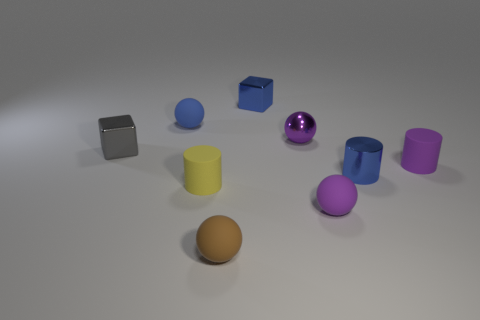There is a metallic thing that is behind the small gray block and in front of the tiny blue rubber object; how big is it?
Give a very brief answer. Small. There is another tiny sphere that is the same color as the small metal sphere; what is its material?
Make the answer very short. Rubber. Are there an equal number of tiny blue metallic cylinders that are behind the brown matte sphere and small purple matte cylinders?
Your response must be concise. Yes. Do the blue shiny cube and the gray block have the same size?
Provide a succinct answer. Yes. There is a tiny sphere that is both on the left side of the small purple metal object and in front of the tiny blue sphere; what is its color?
Your answer should be very brief. Brown. There is a tiny brown ball that is to the right of the small matte thing that is to the left of the yellow thing; what is its material?
Your response must be concise. Rubber. What size is the purple matte object that is the same shape as the brown rubber thing?
Provide a short and direct response. Small. Does the rubber cylinder right of the small blue block have the same color as the small shiny ball?
Provide a short and direct response. Yes. Are there fewer tiny blue objects than tiny brown things?
Keep it short and to the point. No. What number of other objects are the same color as the shiny cylinder?
Offer a terse response. 2. 